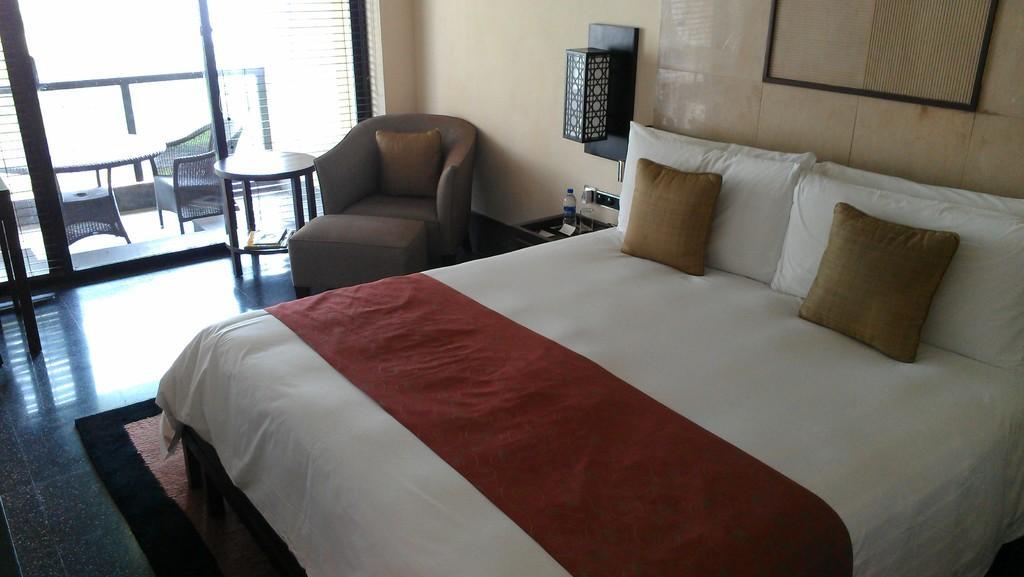Describe this image in one or two sentences. This is a picture of a bedroom. In the foreground of the picture there is a bed, on the bed there are pillows. In the center of the picture there is a couch, table and desk and a lamp. In the top left is there is a railing and table and chairs. In the center of the room there is a water bottle and glass. 